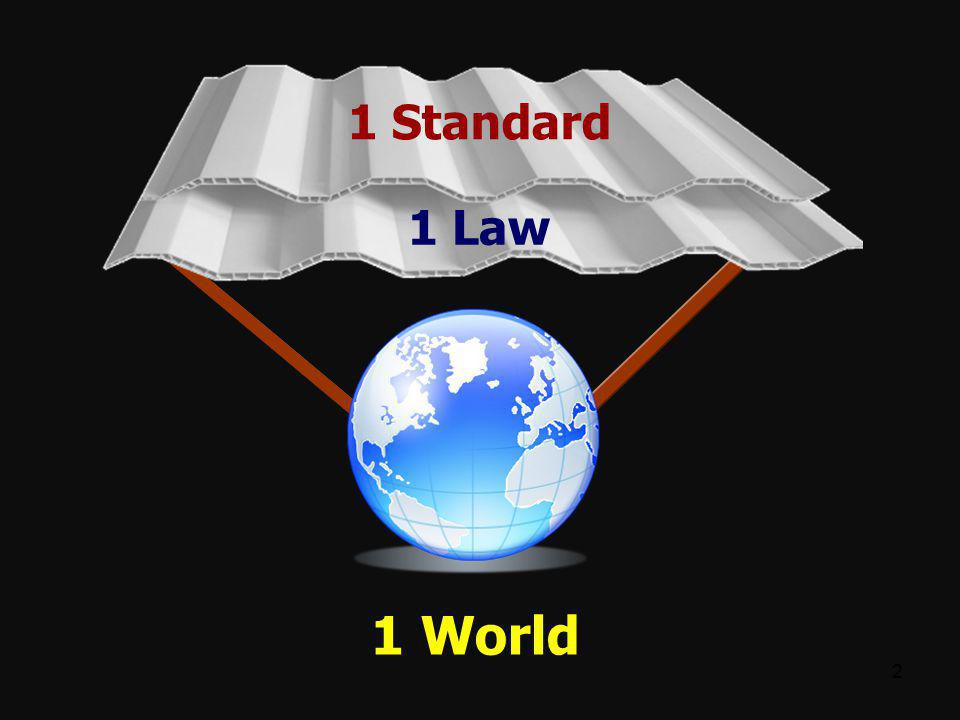What challenges might arise from attempting to implement a united global standard and law? Implementing a unified global standard and law could face numerous challenges, including cultural differences, political resistance, and economic disparities. Nations may find it difficult to reconcile local customs and traditions with a global standard. There might be a lack of trust between countries, leading to resistance against a centralized system. Additionally, varying levels of development could hinder equitable participation, with poorer nations potentially struggling to meet the sharegpt4v/same standards as wealthier ones. Overcoming these challenges requires diplomatic negotiation, incremental adoption, and fostering a global spirit of cooperation and mutual respect. 